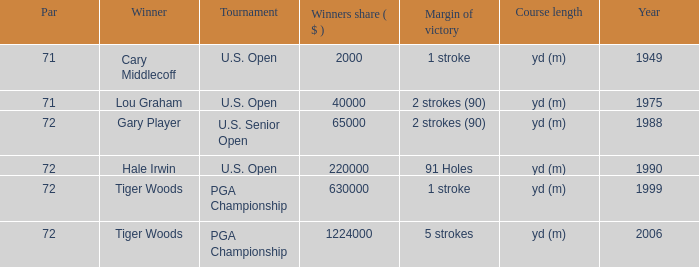When gary player is the winner what is the lowest winners share in dollars? 65000.0. Give me the full table as a dictionary. {'header': ['Par', 'Winner', 'Tournament', 'Winners share ( $ )', 'Margin of victory', 'Course length', 'Year'], 'rows': [['71', 'Cary Middlecoff', 'U.S. Open', '2000', '1 stroke', 'yd (m)', '1949'], ['71', 'Lou Graham', 'U.S. Open', '40000', '2 strokes (90)', 'yd (m)', '1975'], ['72', 'Gary Player', 'U.S. Senior Open', '65000', '2 strokes (90)', 'yd (m)', '1988'], ['72', 'Hale Irwin', 'U.S. Open', '220000', '91 Holes', 'yd (m)', '1990'], ['72', 'Tiger Woods', 'PGA Championship', '630000', '1 stroke', 'yd (m)', '1999'], ['72', 'Tiger Woods', 'PGA Championship', '1224000', '5 strokes', 'yd (m)', '2006']]} 